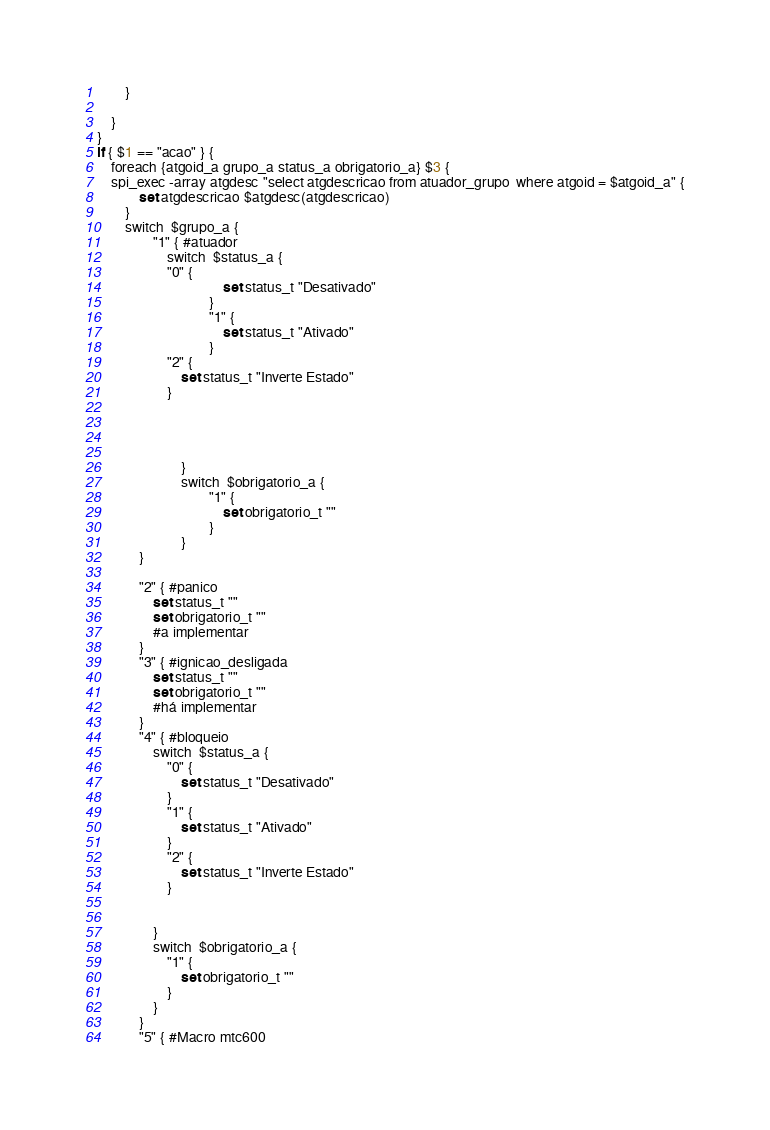<code> <loc_0><loc_0><loc_500><loc_500><_SQL_>		}

	}
}
if { $1 == "acao" } {
	foreach {atgoid_a grupo_a status_a obrigatorio_a} $3 {
	spi_exec -array atgdesc "select atgdescricao from atuador_grupo  where atgoid = $atgoid_a" {
			set atgdescricao $atgdesc(atgdescricao)
		}
		switch  $grupo_a {
      			"1" { #atuador
           			switch  $status_a {
					"0" { 
                         			set status_t "Desativado"
                      			}
                     			"1" {
                          			set status_t "Ativado"
                      			}
					"2" {
						set status_t "Inverte Estado"
					}


                   			

            			}
            			switch  $obrigatorio_a {
                    			"1" { 
                         			set obrigatorio_t ""     
                    			}
            			}
			}

			"2" { #panico
				set status_t ""
				set obrigatorio_t ""
				#a implementar
			}
			"3" { #ignicao_desligada
				set status_t ""
				set obrigatorio_t ""
				#há implementar
			}
			"4" { #bloqueio
				switch  $status_a {
					"0" { 
						set status_t "Desativado"
					}
					"1" { 
						set status_t "Ativado"
					}
					"2" {
						set status_t "Inverte Estado"
					}					


				}
				switch  $obrigatorio_a {
					"1" { 
						set obrigatorio_t ""
					}
				}
			}
			"5" { #Macro mtc600</code> 